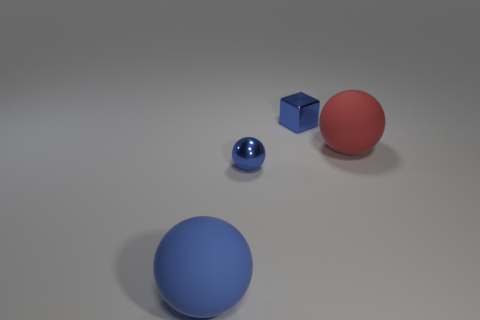Add 1 large matte spheres. How many objects exist? 5 Subtract all balls. How many objects are left? 1 Subtract all tiny cyan metal cubes. Subtract all tiny blue metallic blocks. How many objects are left? 3 Add 4 tiny blue shiny cubes. How many tiny blue shiny cubes are left? 5 Add 1 small blue spheres. How many small blue spheres exist? 2 Subtract 2 blue spheres. How many objects are left? 2 